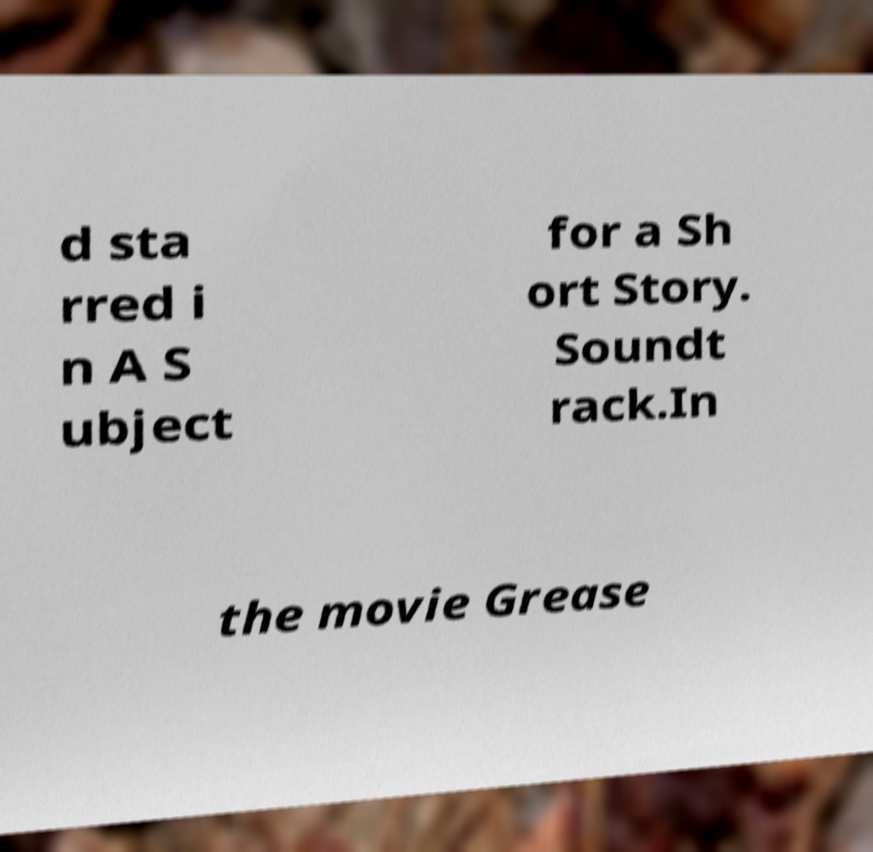What messages or text are displayed in this image? I need them in a readable, typed format. d sta rred i n A S ubject for a Sh ort Story. Soundt rack.In the movie Grease 